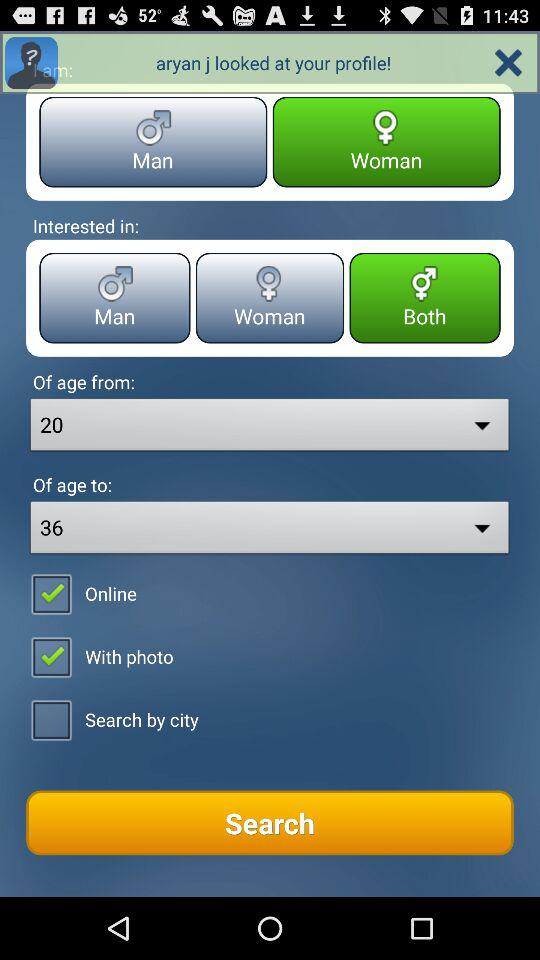What is the gender of the user? The gender of the user is female. 